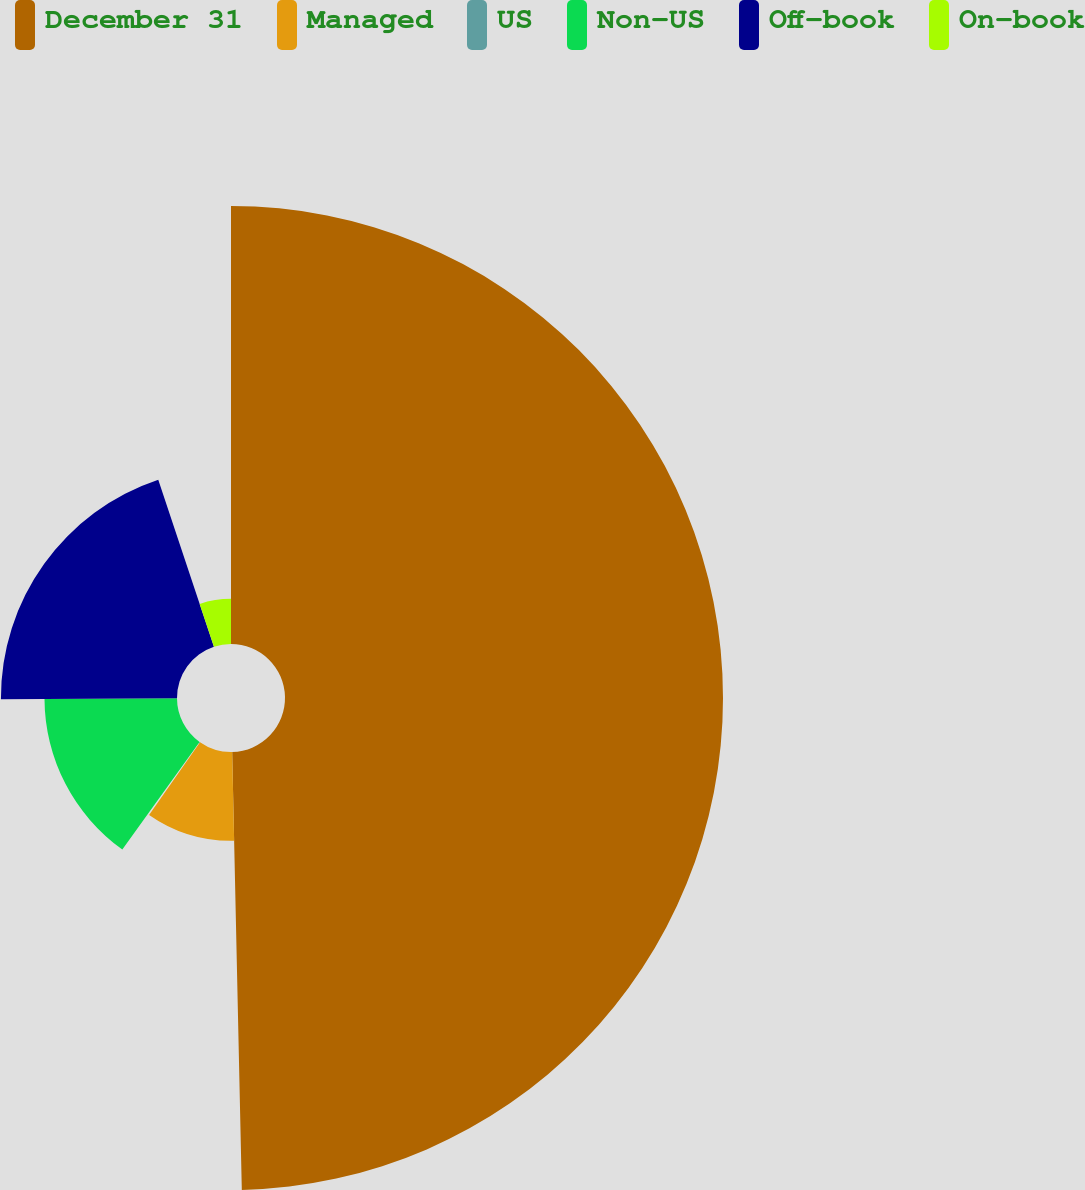<chart> <loc_0><loc_0><loc_500><loc_500><pie_chart><fcel>December 31<fcel>Managed<fcel>US<fcel>Non-US<fcel>Off-book<fcel>On-book<nl><fcel>49.65%<fcel>10.07%<fcel>0.18%<fcel>15.02%<fcel>19.96%<fcel>5.12%<nl></chart> 